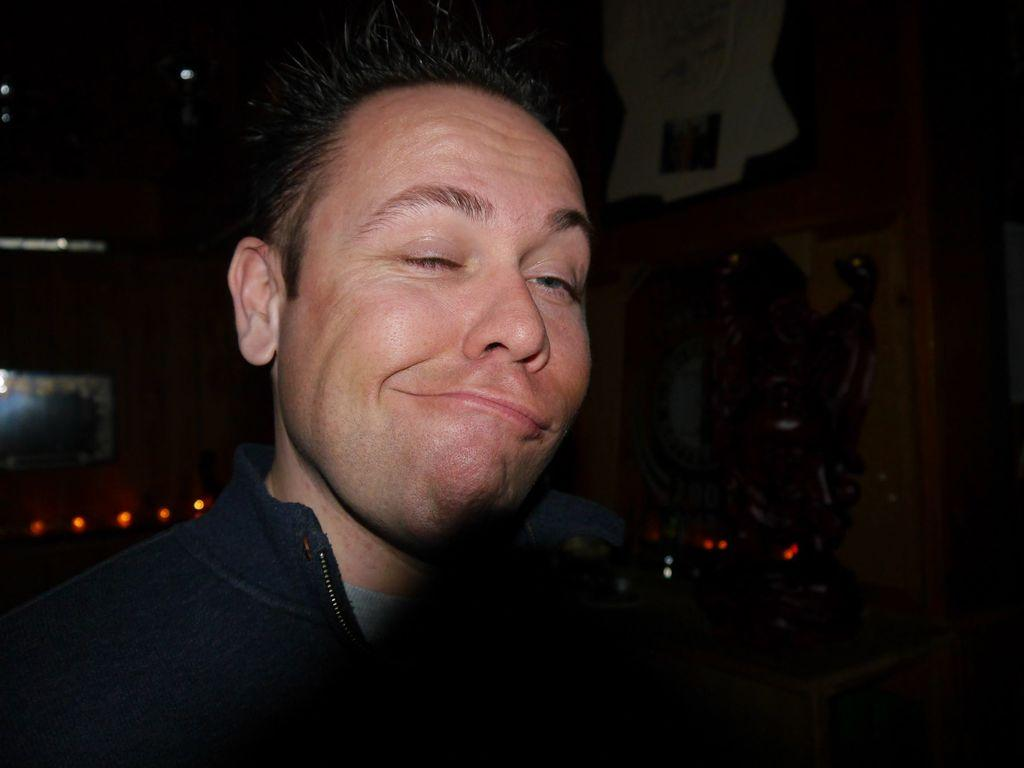Who or what is present in the image? There is a person in the image. What is the person wearing? The person is wearing a blue color jacket. What can be seen in the background of the image? There are lights visible in the background of the image. Where is the maid standing in the image? There is no maid present in the image. What type of spot can be seen on the person's jacket in the image? There is no spot visible on the person's jacket in the image. 